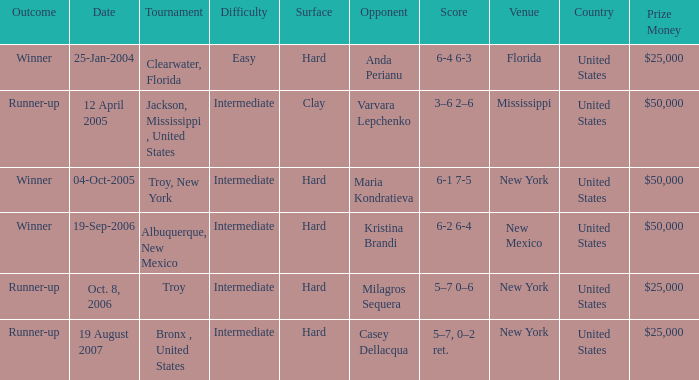Could you parse the entire table as a dict? {'header': ['Outcome', 'Date', 'Tournament', 'Difficulty', 'Surface', 'Opponent', 'Score', 'Venue', 'Country', 'Prize Money'], 'rows': [['Winner', '25-Jan-2004', 'Clearwater, Florida', 'Easy', 'Hard', 'Anda Perianu', '6-4 6-3', 'Florida', 'United States', '$25,000'], ['Runner-up', '12 April 2005', 'Jackson, Mississippi , United States', 'Intermediate', 'Clay', 'Varvara Lepchenko', '3–6 2–6', 'Mississippi', 'United States', '$50,000'], ['Winner', '04-Oct-2005', 'Troy, New York', 'Intermediate', 'Hard', 'Maria Kondratieva', '6-1 7-5', 'New York', 'United States', '$50,000'], ['Winner', '19-Sep-2006', 'Albuquerque, New Mexico', 'Intermediate', 'Hard', 'Kristina Brandi', '6-2 6-4', 'New Mexico', 'United States', '$50,000'], ['Runner-up', 'Oct. 8, 2006', 'Troy', 'Intermediate', 'Hard', 'Milagros Sequera', '5–7 0–6', 'New York', 'United States', '$25,000'], ['Runner-up', '19 August 2007', 'Bronx , United States', 'Intermediate', 'Hard', 'Casey Dellacqua', '5–7, 0–2 ret.', 'New York', 'United States', '$25,000']]} Where was the tournament played on Oct. 8, 2006? Troy. 